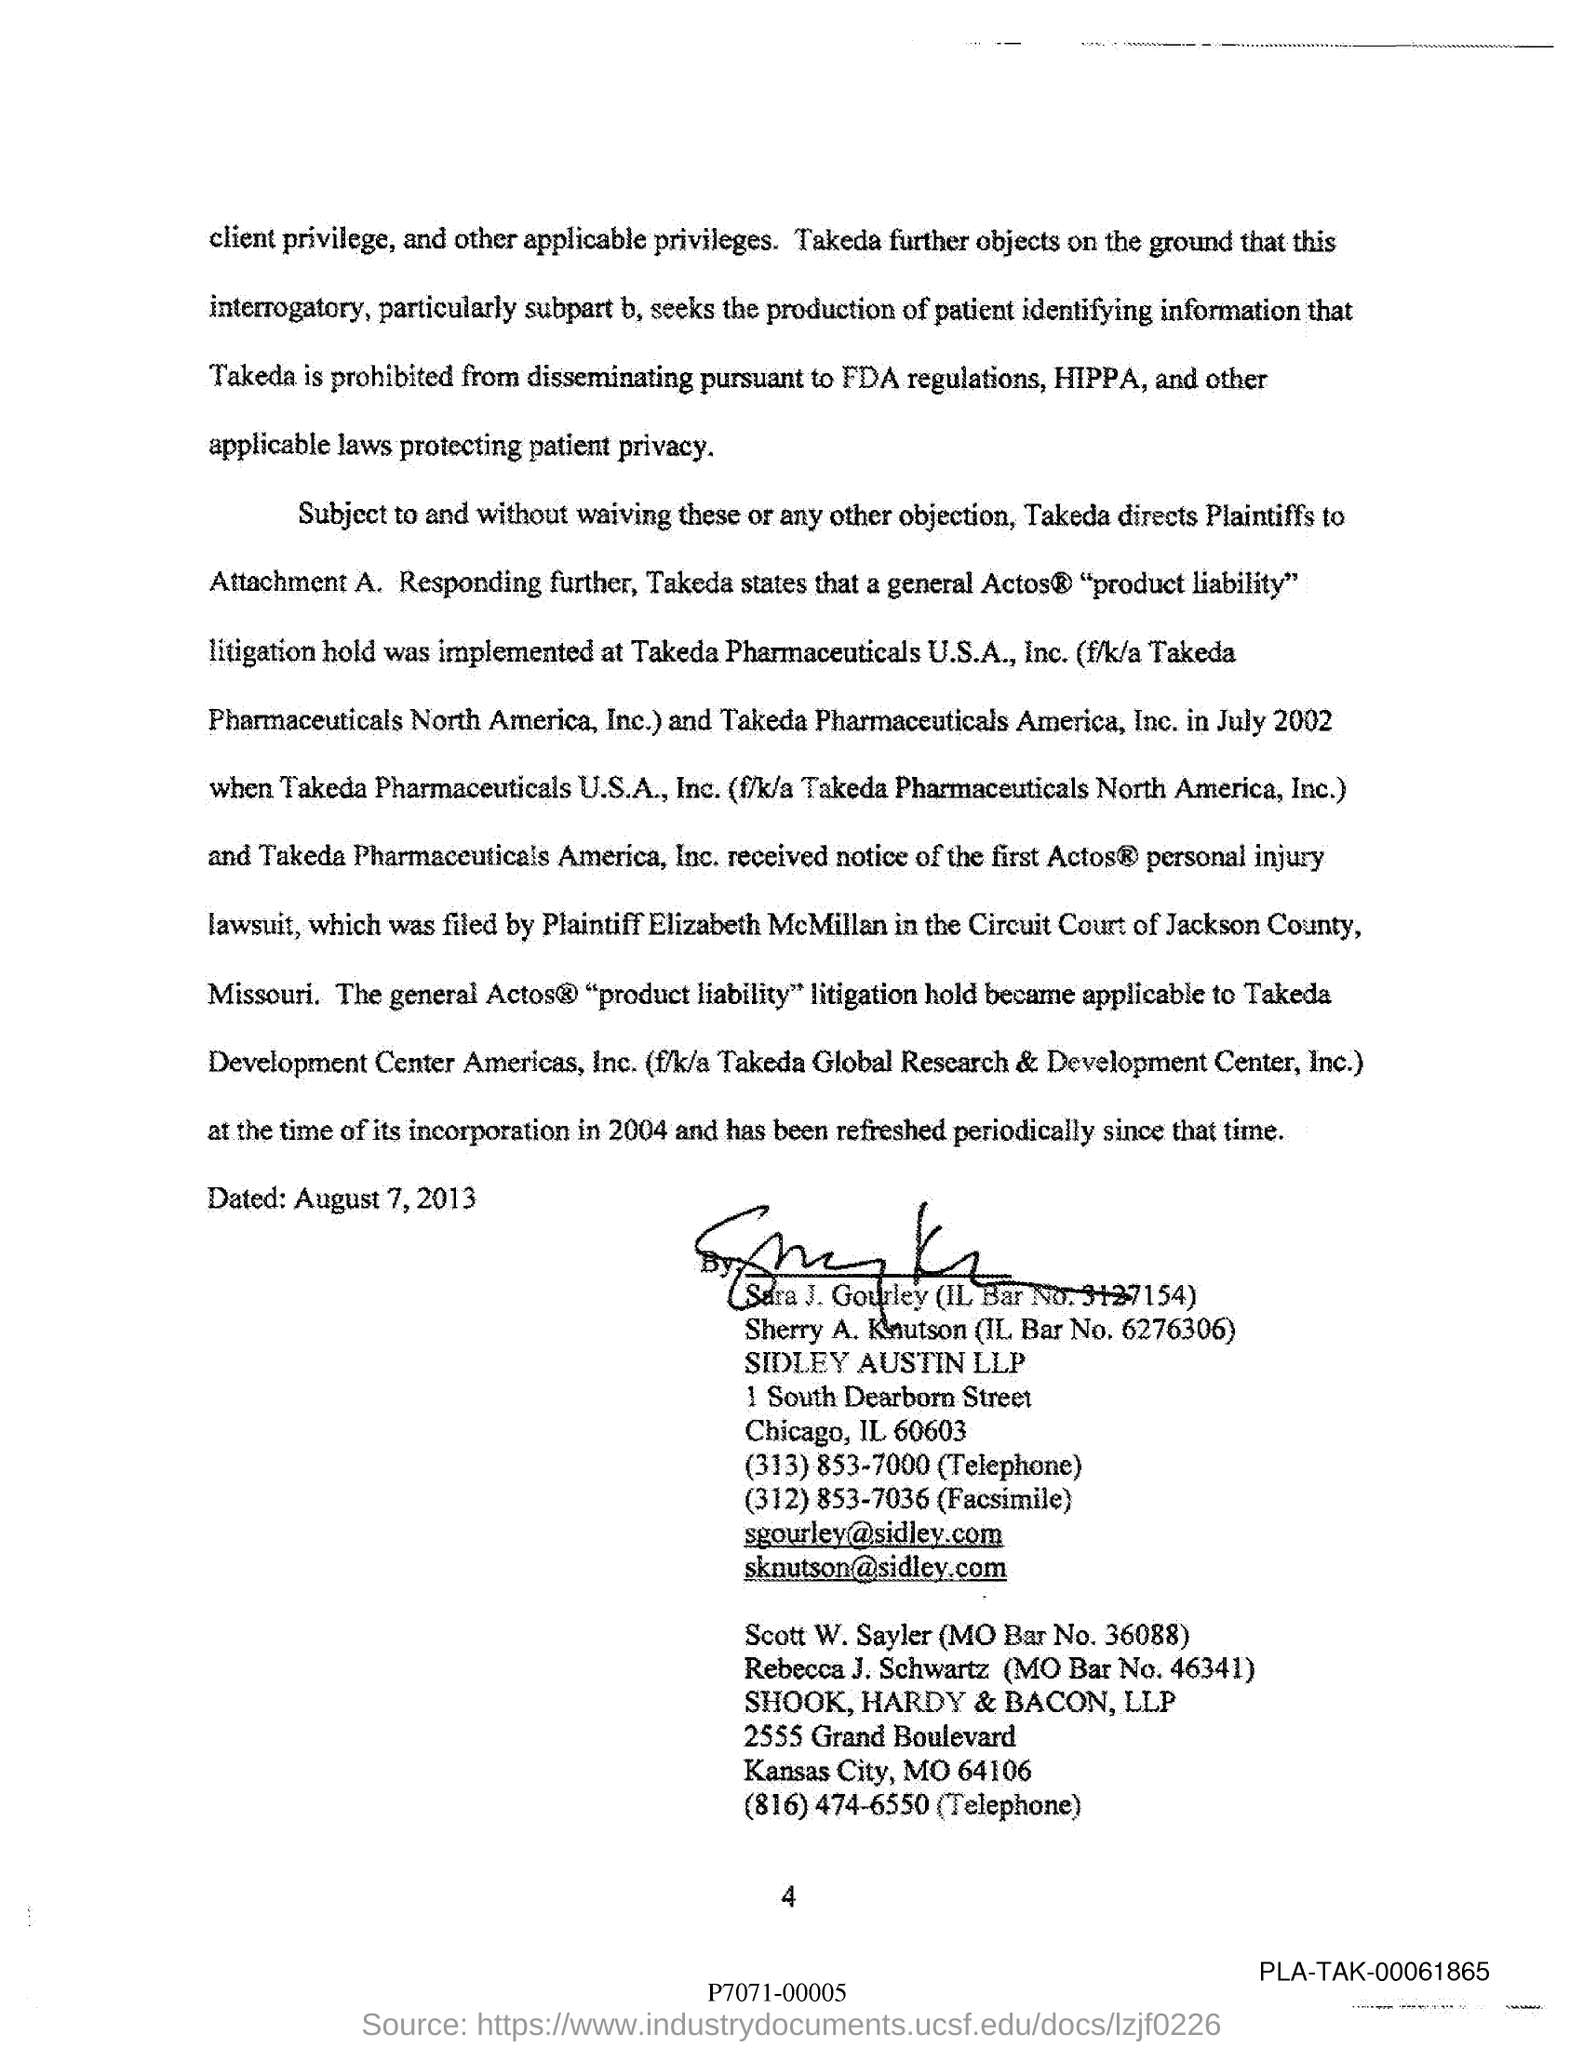What is the MO Bar No. of Scott W. Sayler? The Missouri Bar Number (MO Bar No.) for Scott W. Sayler is 36088, as indicated in the provided legal document. 